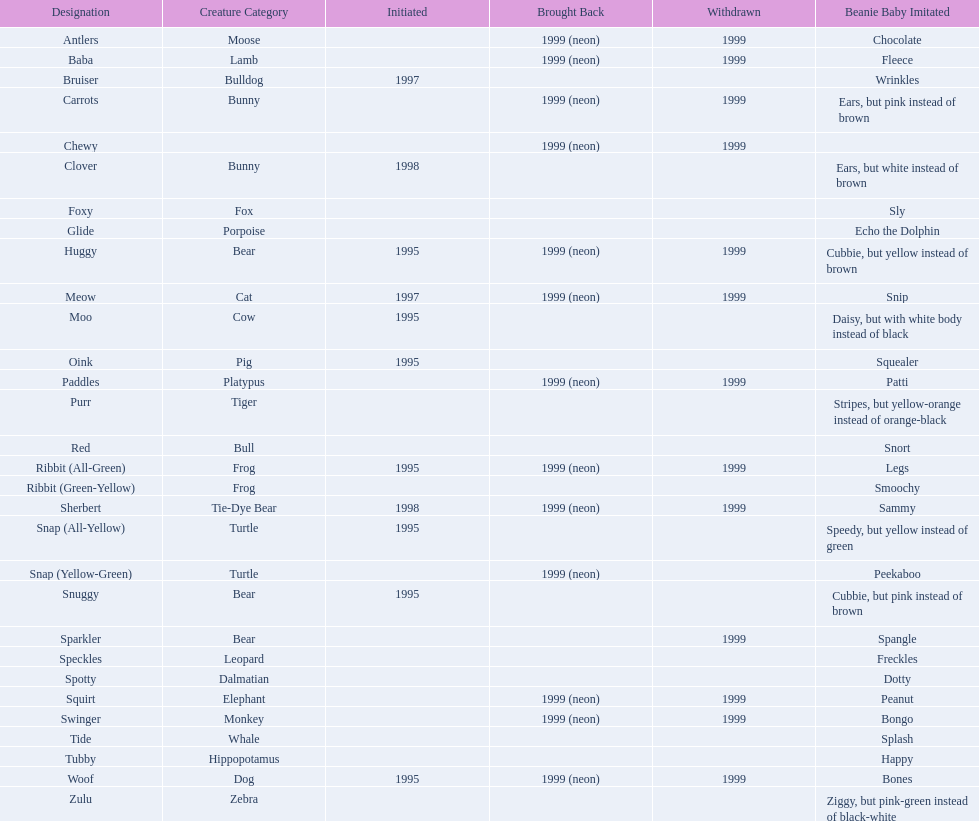What are all the pillow pals? Antlers, Baba, Bruiser, Carrots, Chewy, Clover, Foxy, Glide, Huggy, Meow, Moo, Oink, Paddles, Purr, Red, Ribbit (All-Green), Ribbit (Green-Yellow), Sherbert, Snap (All-Yellow), Snap (Yellow-Green), Snuggy, Sparkler, Speckles, Spotty, Squirt, Swinger, Tide, Tubby, Woof, Zulu. Which is the only without a listed animal type? Chewy. 